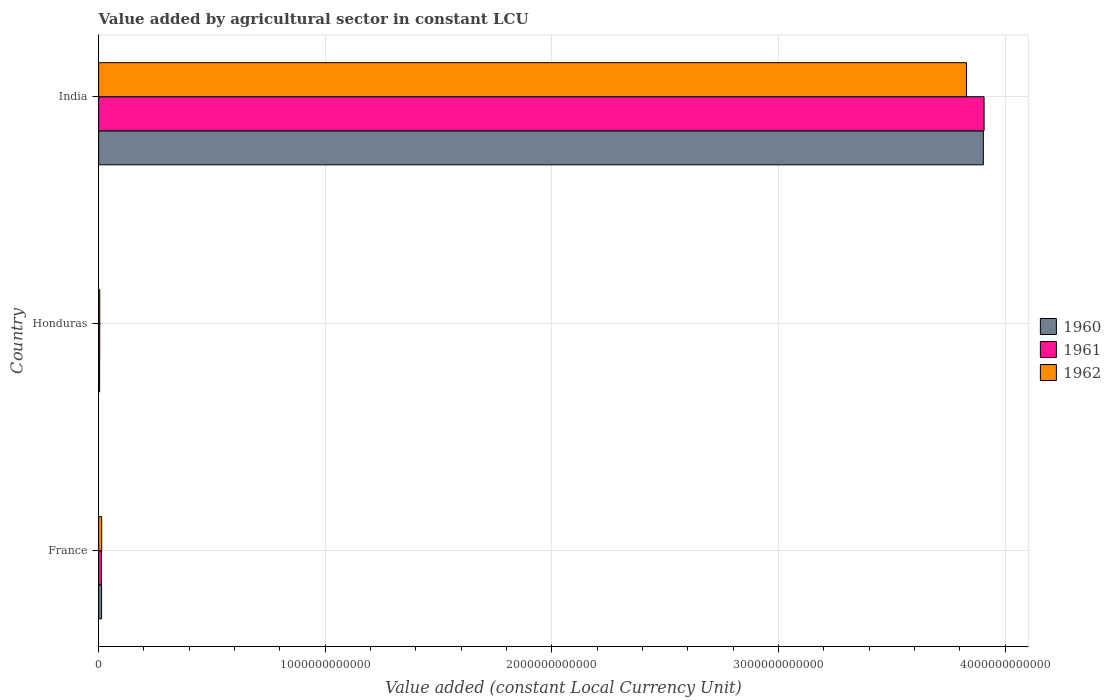How many different coloured bars are there?
Keep it short and to the point. 3. How many groups of bars are there?
Provide a short and direct response. 3. Are the number of bars on each tick of the Y-axis equal?
Ensure brevity in your answer.  Yes. What is the label of the 3rd group of bars from the top?
Your answer should be compact. France. In how many cases, is the number of bars for a given country not equal to the number of legend labels?
Keep it short and to the point. 0. What is the value added by agricultural sector in 1961 in France?
Provide a succinct answer. 1.25e+1. Across all countries, what is the maximum value added by agricultural sector in 1962?
Provide a short and direct response. 3.83e+12. Across all countries, what is the minimum value added by agricultural sector in 1962?
Your answer should be very brief. 4.96e+09. In which country was the value added by agricultural sector in 1962 maximum?
Make the answer very short. India. In which country was the value added by agricultural sector in 1960 minimum?
Keep it short and to the point. Honduras. What is the total value added by agricultural sector in 1962 in the graph?
Your answer should be compact. 3.85e+12. What is the difference between the value added by agricultural sector in 1960 in France and that in Honduras?
Make the answer very short. 8.72e+09. What is the difference between the value added by agricultural sector in 1960 in India and the value added by agricultural sector in 1962 in Honduras?
Keep it short and to the point. 3.90e+12. What is the average value added by agricultural sector in 1961 per country?
Provide a succinct answer. 1.31e+12. What is the difference between the value added by agricultural sector in 1961 and value added by agricultural sector in 1960 in France?
Offer a terse response. -6.84e+08. What is the ratio of the value added by agricultural sector in 1960 in France to that in Honduras?
Provide a succinct answer. 2.96. What is the difference between the highest and the second highest value added by agricultural sector in 1960?
Make the answer very short. 3.89e+12. What is the difference between the highest and the lowest value added by agricultural sector in 1961?
Give a very brief answer. 3.90e+12. Is it the case that in every country, the sum of the value added by agricultural sector in 1961 and value added by agricultural sector in 1962 is greater than the value added by agricultural sector in 1960?
Make the answer very short. Yes. How many bars are there?
Provide a short and direct response. 9. Are all the bars in the graph horizontal?
Offer a very short reply. Yes. What is the difference between two consecutive major ticks on the X-axis?
Your answer should be compact. 1.00e+12. Are the values on the major ticks of X-axis written in scientific E-notation?
Offer a terse response. No. How many legend labels are there?
Provide a short and direct response. 3. How are the legend labels stacked?
Give a very brief answer. Vertical. What is the title of the graph?
Give a very brief answer. Value added by agricultural sector in constant LCU. What is the label or title of the X-axis?
Provide a succinct answer. Value added (constant Local Currency Unit). What is the Value added (constant Local Currency Unit) of 1960 in France?
Your response must be concise. 1.32e+1. What is the Value added (constant Local Currency Unit) of 1961 in France?
Give a very brief answer. 1.25e+1. What is the Value added (constant Local Currency Unit) in 1962 in France?
Your answer should be compact. 1.36e+1. What is the Value added (constant Local Currency Unit) of 1960 in Honduras?
Your response must be concise. 4.44e+09. What is the Value added (constant Local Currency Unit) of 1961 in Honduras?
Your answer should be very brief. 4.73e+09. What is the Value added (constant Local Currency Unit) of 1962 in Honduras?
Give a very brief answer. 4.96e+09. What is the Value added (constant Local Currency Unit) of 1960 in India?
Give a very brief answer. 3.90e+12. What is the Value added (constant Local Currency Unit) in 1961 in India?
Provide a succinct answer. 3.91e+12. What is the Value added (constant Local Currency Unit) of 1962 in India?
Provide a short and direct response. 3.83e+12. Across all countries, what is the maximum Value added (constant Local Currency Unit) of 1960?
Offer a terse response. 3.90e+12. Across all countries, what is the maximum Value added (constant Local Currency Unit) of 1961?
Your answer should be compact. 3.91e+12. Across all countries, what is the maximum Value added (constant Local Currency Unit) of 1962?
Your answer should be very brief. 3.83e+12. Across all countries, what is the minimum Value added (constant Local Currency Unit) in 1960?
Provide a short and direct response. 4.44e+09. Across all countries, what is the minimum Value added (constant Local Currency Unit) of 1961?
Your response must be concise. 4.73e+09. Across all countries, what is the minimum Value added (constant Local Currency Unit) of 1962?
Give a very brief answer. 4.96e+09. What is the total Value added (constant Local Currency Unit) in 1960 in the graph?
Offer a terse response. 3.92e+12. What is the total Value added (constant Local Currency Unit) of 1961 in the graph?
Provide a short and direct response. 3.92e+12. What is the total Value added (constant Local Currency Unit) in 1962 in the graph?
Keep it short and to the point. 3.85e+12. What is the difference between the Value added (constant Local Currency Unit) of 1960 in France and that in Honduras?
Make the answer very short. 8.72e+09. What is the difference between the Value added (constant Local Currency Unit) in 1961 in France and that in Honduras?
Your response must be concise. 7.74e+09. What is the difference between the Value added (constant Local Currency Unit) in 1962 in France and that in Honduras?
Your answer should be compact. 8.63e+09. What is the difference between the Value added (constant Local Currency Unit) in 1960 in France and that in India?
Your answer should be compact. -3.89e+12. What is the difference between the Value added (constant Local Currency Unit) in 1961 in France and that in India?
Make the answer very short. -3.90e+12. What is the difference between the Value added (constant Local Currency Unit) of 1962 in France and that in India?
Your answer should be compact. -3.82e+12. What is the difference between the Value added (constant Local Currency Unit) in 1960 in Honduras and that in India?
Offer a terse response. -3.90e+12. What is the difference between the Value added (constant Local Currency Unit) in 1961 in Honduras and that in India?
Ensure brevity in your answer.  -3.90e+12. What is the difference between the Value added (constant Local Currency Unit) in 1962 in Honduras and that in India?
Your answer should be very brief. -3.82e+12. What is the difference between the Value added (constant Local Currency Unit) of 1960 in France and the Value added (constant Local Currency Unit) of 1961 in Honduras?
Give a very brief answer. 8.43e+09. What is the difference between the Value added (constant Local Currency Unit) of 1960 in France and the Value added (constant Local Currency Unit) of 1962 in Honduras?
Your answer should be compact. 8.20e+09. What is the difference between the Value added (constant Local Currency Unit) of 1961 in France and the Value added (constant Local Currency Unit) of 1962 in Honduras?
Make the answer very short. 7.52e+09. What is the difference between the Value added (constant Local Currency Unit) of 1960 in France and the Value added (constant Local Currency Unit) of 1961 in India?
Offer a very short reply. -3.89e+12. What is the difference between the Value added (constant Local Currency Unit) in 1960 in France and the Value added (constant Local Currency Unit) in 1962 in India?
Your answer should be very brief. -3.82e+12. What is the difference between the Value added (constant Local Currency Unit) of 1961 in France and the Value added (constant Local Currency Unit) of 1962 in India?
Your answer should be very brief. -3.82e+12. What is the difference between the Value added (constant Local Currency Unit) of 1960 in Honduras and the Value added (constant Local Currency Unit) of 1961 in India?
Your answer should be compact. -3.90e+12. What is the difference between the Value added (constant Local Currency Unit) in 1960 in Honduras and the Value added (constant Local Currency Unit) in 1962 in India?
Keep it short and to the point. -3.83e+12. What is the difference between the Value added (constant Local Currency Unit) of 1961 in Honduras and the Value added (constant Local Currency Unit) of 1962 in India?
Provide a succinct answer. -3.83e+12. What is the average Value added (constant Local Currency Unit) of 1960 per country?
Your response must be concise. 1.31e+12. What is the average Value added (constant Local Currency Unit) in 1961 per country?
Your answer should be very brief. 1.31e+12. What is the average Value added (constant Local Currency Unit) in 1962 per country?
Make the answer very short. 1.28e+12. What is the difference between the Value added (constant Local Currency Unit) in 1960 and Value added (constant Local Currency Unit) in 1961 in France?
Your answer should be compact. 6.84e+08. What is the difference between the Value added (constant Local Currency Unit) in 1960 and Value added (constant Local Currency Unit) in 1962 in France?
Offer a very short reply. -4.23e+08. What is the difference between the Value added (constant Local Currency Unit) in 1961 and Value added (constant Local Currency Unit) in 1962 in France?
Your answer should be compact. -1.11e+09. What is the difference between the Value added (constant Local Currency Unit) in 1960 and Value added (constant Local Currency Unit) in 1961 in Honduras?
Offer a very short reply. -2.90e+08. What is the difference between the Value added (constant Local Currency Unit) of 1960 and Value added (constant Local Currency Unit) of 1962 in Honduras?
Offer a very short reply. -5.15e+08. What is the difference between the Value added (constant Local Currency Unit) in 1961 and Value added (constant Local Currency Unit) in 1962 in Honduras?
Make the answer very short. -2.25e+08. What is the difference between the Value added (constant Local Currency Unit) in 1960 and Value added (constant Local Currency Unit) in 1961 in India?
Make the answer very short. -3.29e+09. What is the difference between the Value added (constant Local Currency Unit) of 1960 and Value added (constant Local Currency Unit) of 1962 in India?
Make the answer very short. 7.44e+1. What is the difference between the Value added (constant Local Currency Unit) of 1961 and Value added (constant Local Currency Unit) of 1962 in India?
Keep it short and to the point. 7.77e+1. What is the ratio of the Value added (constant Local Currency Unit) in 1960 in France to that in Honduras?
Your answer should be compact. 2.96. What is the ratio of the Value added (constant Local Currency Unit) in 1961 in France to that in Honduras?
Offer a terse response. 2.64. What is the ratio of the Value added (constant Local Currency Unit) of 1962 in France to that in Honduras?
Ensure brevity in your answer.  2.74. What is the ratio of the Value added (constant Local Currency Unit) in 1960 in France to that in India?
Offer a terse response. 0. What is the ratio of the Value added (constant Local Currency Unit) in 1961 in France to that in India?
Your answer should be very brief. 0. What is the ratio of the Value added (constant Local Currency Unit) in 1962 in France to that in India?
Ensure brevity in your answer.  0. What is the ratio of the Value added (constant Local Currency Unit) of 1960 in Honduras to that in India?
Offer a very short reply. 0. What is the ratio of the Value added (constant Local Currency Unit) in 1961 in Honduras to that in India?
Keep it short and to the point. 0. What is the ratio of the Value added (constant Local Currency Unit) in 1962 in Honduras to that in India?
Keep it short and to the point. 0. What is the difference between the highest and the second highest Value added (constant Local Currency Unit) in 1960?
Provide a succinct answer. 3.89e+12. What is the difference between the highest and the second highest Value added (constant Local Currency Unit) in 1961?
Offer a terse response. 3.90e+12. What is the difference between the highest and the second highest Value added (constant Local Currency Unit) in 1962?
Provide a short and direct response. 3.82e+12. What is the difference between the highest and the lowest Value added (constant Local Currency Unit) of 1960?
Make the answer very short. 3.90e+12. What is the difference between the highest and the lowest Value added (constant Local Currency Unit) of 1961?
Offer a terse response. 3.90e+12. What is the difference between the highest and the lowest Value added (constant Local Currency Unit) in 1962?
Keep it short and to the point. 3.82e+12. 